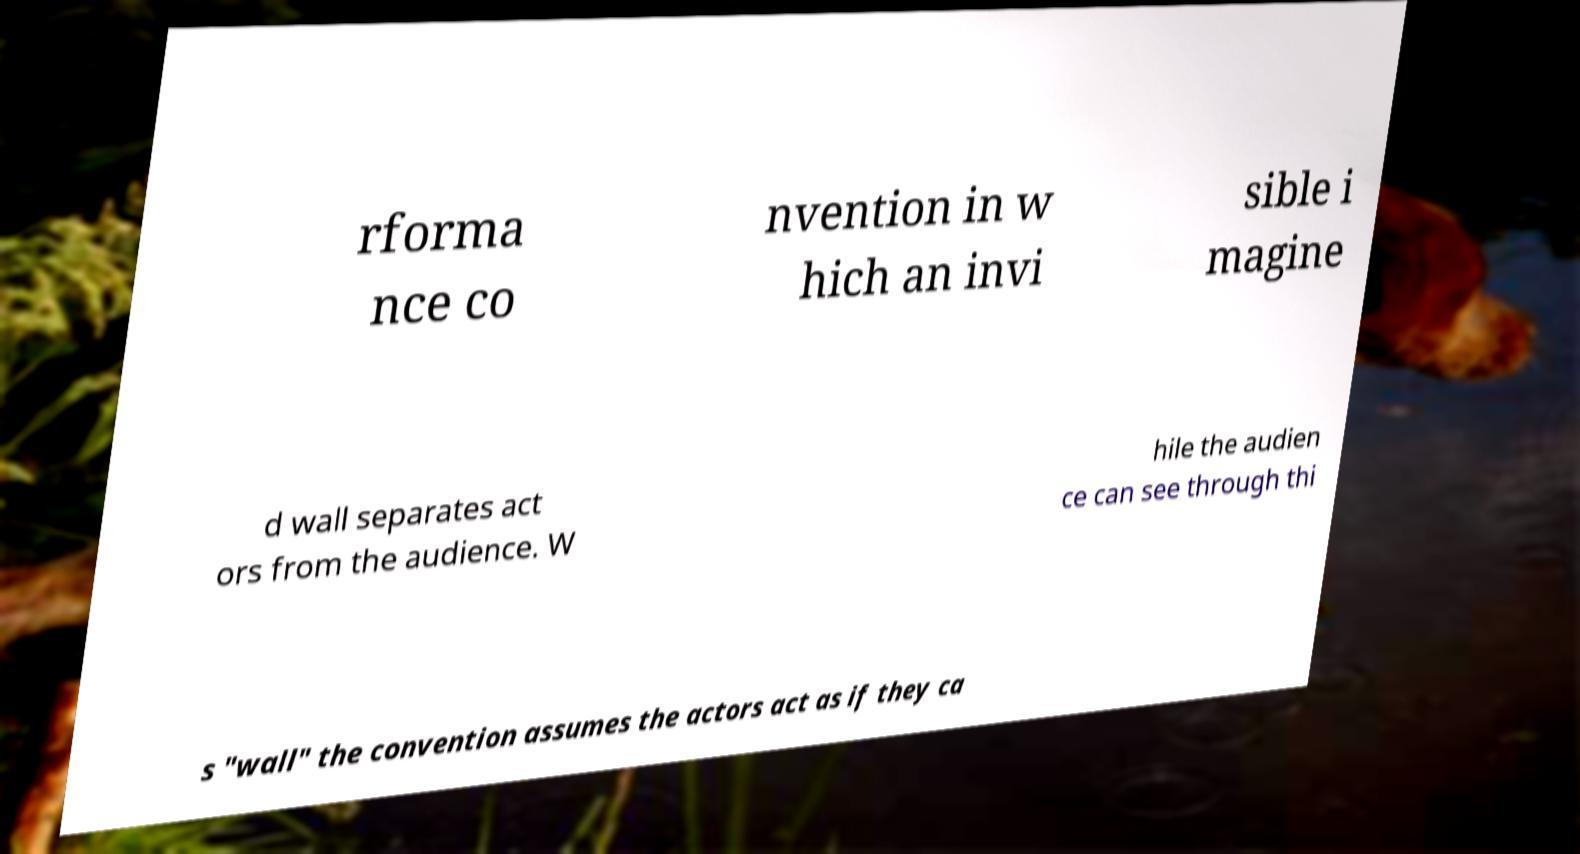Can you read and provide the text displayed in the image?This photo seems to have some interesting text. Can you extract and type it out for me? rforma nce co nvention in w hich an invi sible i magine d wall separates act ors from the audience. W hile the audien ce can see through thi s "wall" the convention assumes the actors act as if they ca 